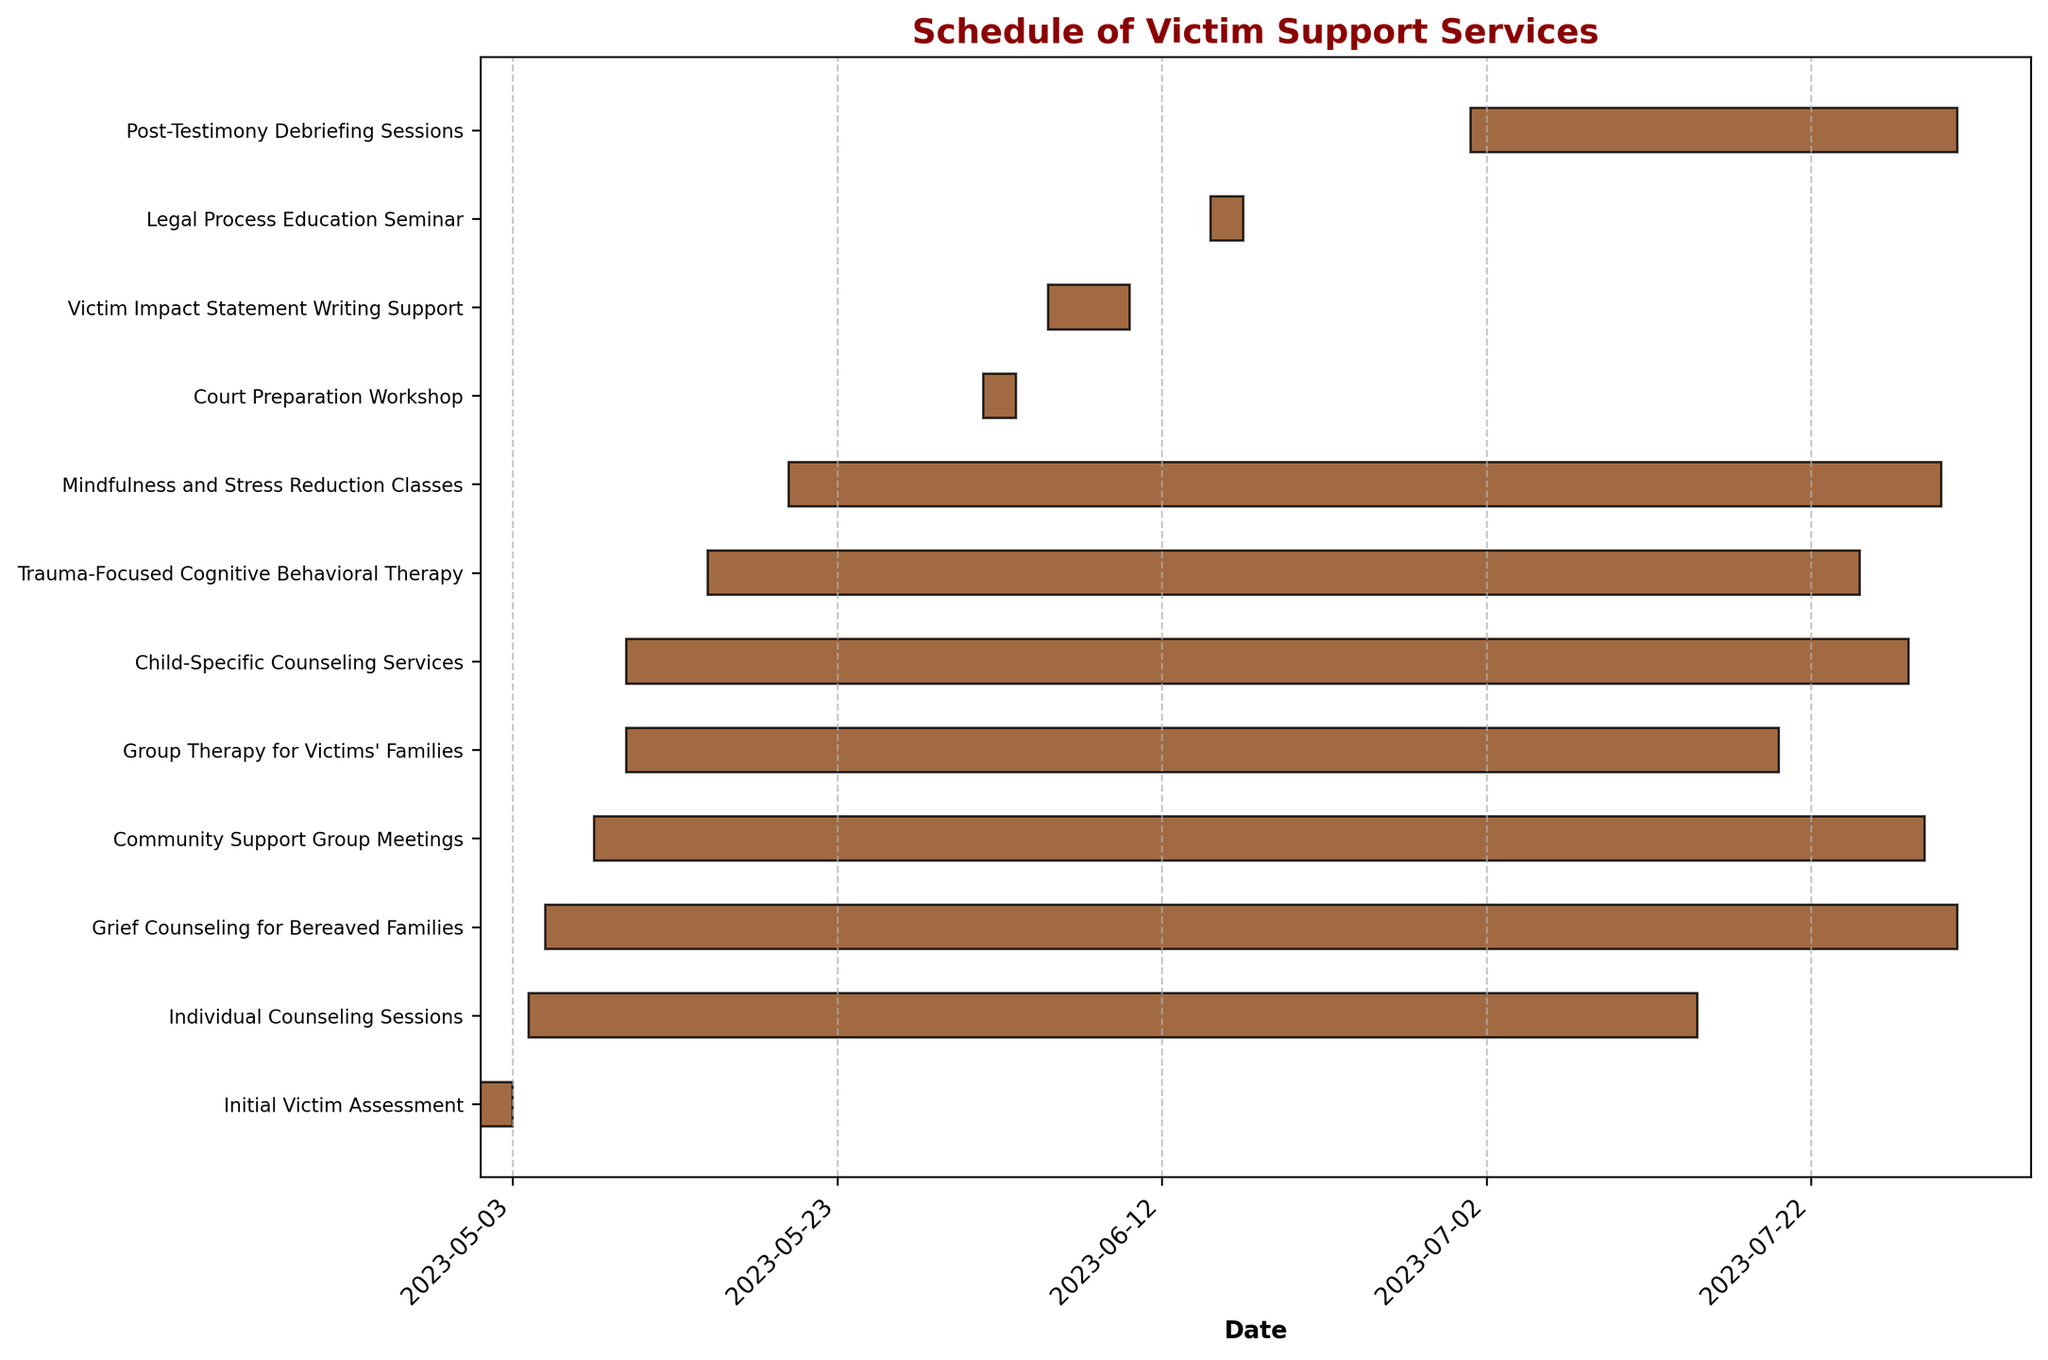What is the title of the chart? The title of the chart is usually located at the top of the figure to give an overview of what the chart is about. In this case, it explicitly mentions the schedule.
Answer: Schedule of Victim Support Services Which task has the longest duration? To determine the task with the longest duration, look at the length of the horizontal bars. The longest bar represents the longest duration.
Answer: Grief Counseling for Bereaved Families When does the 'Victim Impact Statement Writing Support' task start and end? Locate the horizontal bar corresponding to 'Victim Impact Statement Writing Support' and note its start and end points on the date axis.
Answer: Starts: 2023-06-05, Ends: 2023-06-10 How many tasks start in May? Count the number of horizontal bars (tasks) that have start dates within the month of May by referring to the start date axis.
Answer: 10 What is the difference in duration between 'Initial Victim Assessment' and 'Trauma-Focused Cognitive Behavioral Therapy'? Calculate the duration of both tasks by subtracting the start date from the end date for each task, then find the difference between these two durations.
Answer: Difference: 74 days Which task ends last? Look for the farthest right end point among all horizontal bars to identify which task has the latest end date.
Answer: Grief Counseling for Bereaved Families Are there any tasks that overlap in terms of time? Look for horizontal bars that span the same date ranges or have their durations overlap in the timeline to determine any overlap.
Answer: Yes, many tasks overlap, e.g., Individual Counseling Sessions and Group Therapy for Victims' Families During which month does 'Court Preparation Workshop' occur? Identify the start and end dates of the 'Court Preparation Workshop' task and note the month(s) within its duration.
Answer: June How many tasks end in July? Count the number of tasks that have their end dates within the month of July by referring to the end date axis.
Answer: 8 What support service task starts immediately after 'Initial Victim Assessment'? Compare the end date of 'Initial Victim Assessment' with the start dates of other tasks to find the one that starts right after it.
Answer: Individual Counseling Sessions 